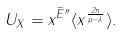<formula> <loc_0><loc_0><loc_500><loc_500>U _ { X } = x ^ { \widetilde { E } ^ { \prime \prime } } \langle x ^ { \frac { 2 n } { \mu - \lambda } } \rangle .</formula> 